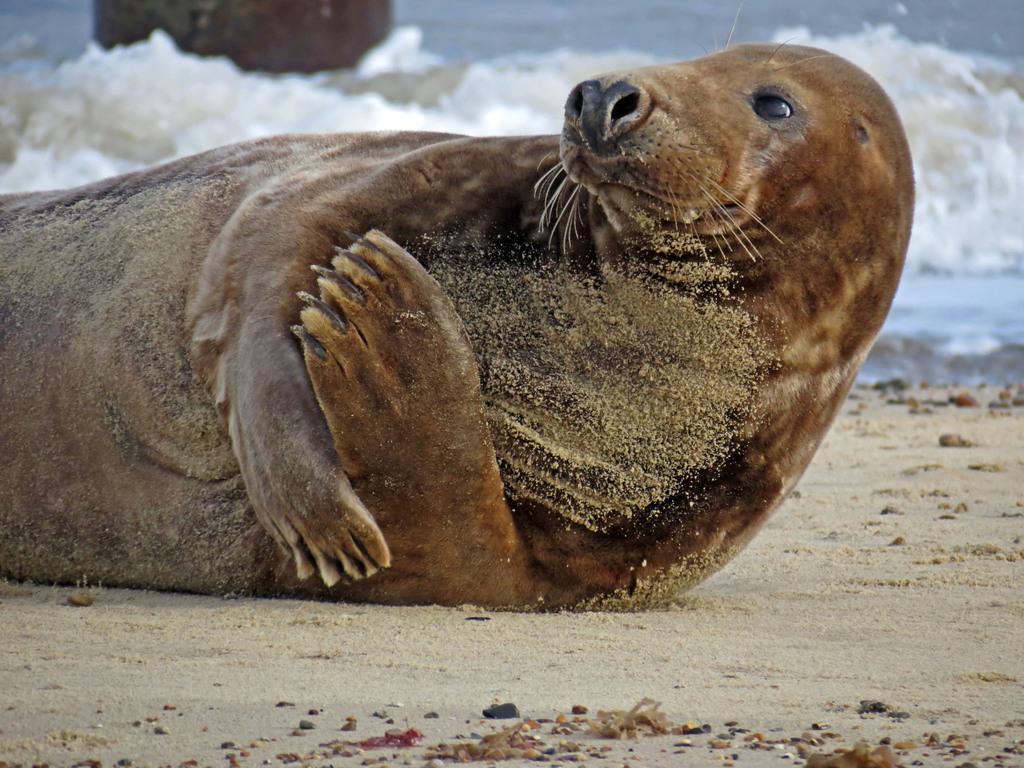Please provide a concise description of this image. In the picture we can see the sea lion on the sand surface and behind it we can see the water. 